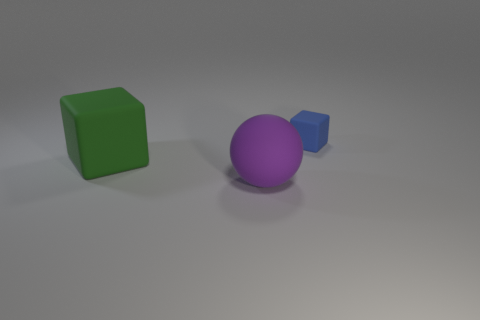What color is the ball?
Offer a terse response. Purple. How many big purple objects are there?
Your response must be concise. 1. What number of objects have the same color as the sphere?
Make the answer very short. 0. There is a rubber object to the left of the matte sphere; is its shape the same as the rubber thing that is behind the big cube?
Make the answer very short. Yes. The big rubber thing behind the matte thing that is in front of the object that is to the left of the large purple rubber object is what color?
Keep it short and to the point. Green. What is the color of the large matte object that is in front of the large cube?
Provide a short and direct response. Purple. The thing that is the same size as the green rubber block is what color?
Your answer should be very brief. Purple. Is the green matte object the same size as the purple thing?
Your response must be concise. Yes. What number of large green matte blocks are on the left side of the tiny rubber block?
Keep it short and to the point. 1. What number of objects are either big green cubes behind the big purple thing or small blue cubes?
Your answer should be compact. 2. 